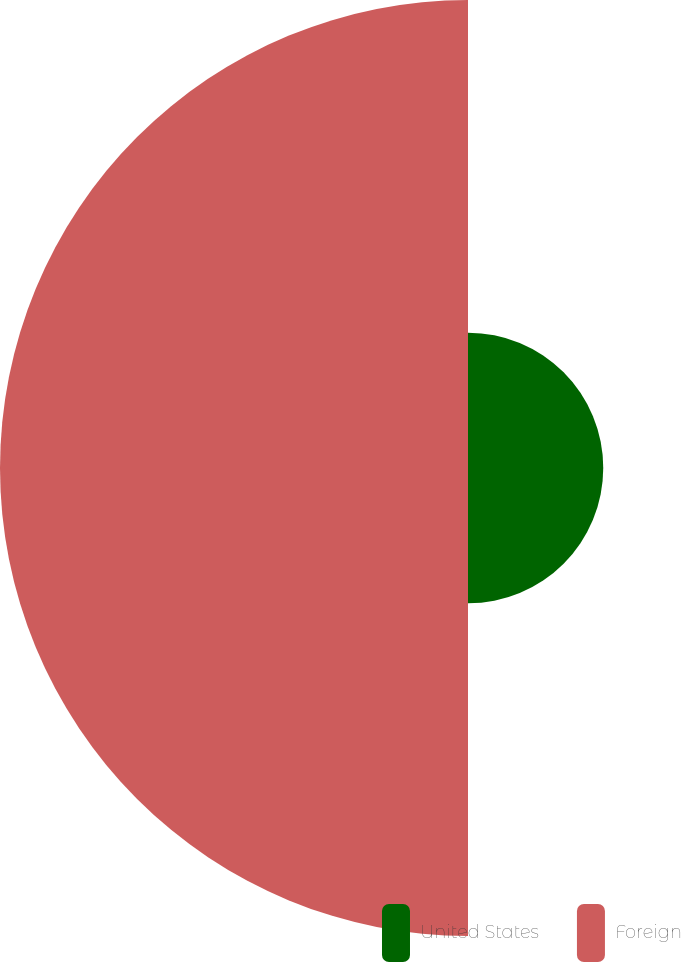Convert chart to OTSL. <chart><loc_0><loc_0><loc_500><loc_500><pie_chart><fcel>United States<fcel>Foreign<nl><fcel>22.42%<fcel>77.58%<nl></chart> 